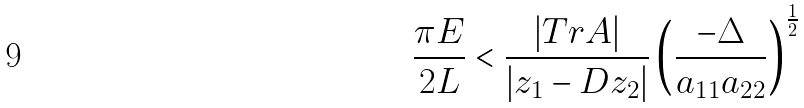<formula> <loc_0><loc_0><loc_500><loc_500>\frac { \pi E } { 2 L } < \frac { | T r A | } { | z _ { 1 } - D z _ { 2 } | } \left ( \frac { - \Delta } { a _ { 1 1 } a _ { 2 2 } } \right ) ^ { \frac { 1 } { 2 } }</formula> 